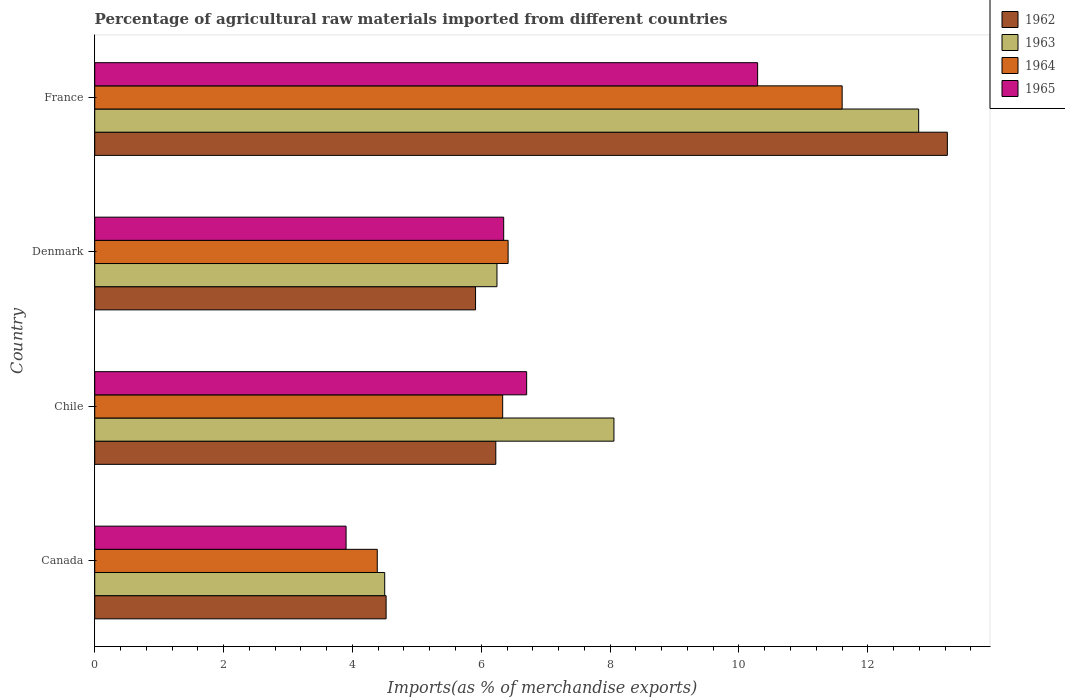How many different coloured bars are there?
Provide a succinct answer. 4. Are the number of bars per tick equal to the number of legend labels?
Give a very brief answer. Yes. Are the number of bars on each tick of the Y-axis equal?
Make the answer very short. Yes. What is the percentage of imports to different countries in 1962 in France?
Give a very brief answer. 13.24. Across all countries, what is the maximum percentage of imports to different countries in 1963?
Your answer should be very brief. 12.79. Across all countries, what is the minimum percentage of imports to different countries in 1962?
Offer a very short reply. 4.52. What is the total percentage of imports to different countries in 1964 in the graph?
Offer a very short reply. 28.74. What is the difference between the percentage of imports to different countries in 1965 in Canada and that in Chile?
Give a very brief answer. -2.8. What is the difference between the percentage of imports to different countries in 1963 in Denmark and the percentage of imports to different countries in 1964 in Canada?
Offer a very short reply. 1.86. What is the average percentage of imports to different countries in 1962 per country?
Your response must be concise. 7.47. What is the difference between the percentage of imports to different countries in 1965 and percentage of imports to different countries in 1962 in France?
Keep it short and to the point. -2.95. What is the ratio of the percentage of imports to different countries in 1962 in Canada to that in Chile?
Offer a very short reply. 0.73. Is the percentage of imports to different countries in 1963 in Canada less than that in Chile?
Offer a very short reply. Yes. Is the difference between the percentage of imports to different countries in 1965 in Chile and Denmark greater than the difference between the percentage of imports to different countries in 1962 in Chile and Denmark?
Provide a short and direct response. Yes. What is the difference between the highest and the second highest percentage of imports to different countries in 1962?
Give a very brief answer. 7.01. What is the difference between the highest and the lowest percentage of imports to different countries in 1962?
Make the answer very short. 8.71. In how many countries, is the percentage of imports to different countries in 1965 greater than the average percentage of imports to different countries in 1965 taken over all countries?
Ensure brevity in your answer.  1. What does the 1st bar from the top in Denmark represents?
Provide a short and direct response. 1965. How many bars are there?
Make the answer very short. 16. What is the difference between two consecutive major ticks on the X-axis?
Offer a very short reply. 2. Are the values on the major ticks of X-axis written in scientific E-notation?
Keep it short and to the point. No. Does the graph contain grids?
Ensure brevity in your answer.  No. How are the legend labels stacked?
Provide a succinct answer. Vertical. What is the title of the graph?
Ensure brevity in your answer.  Percentage of agricultural raw materials imported from different countries. What is the label or title of the X-axis?
Make the answer very short. Imports(as % of merchandise exports). What is the Imports(as % of merchandise exports) of 1962 in Canada?
Keep it short and to the point. 4.52. What is the Imports(as % of merchandise exports) of 1963 in Canada?
Your answer should be very brief. 4.5. What is the Imports(as % of merchandise exports) in 1964 in Canada?
Provide a short and direct response. 4.39. What is the Imports(as % of merchandise exports) in 1965 in Canada?
Keep it short and to the point. 3.9. What is the Imports(as % of merchandise exports) of 1962 in Chile?
Ensure brevity in your answer.  6.23. What is the Imports(as % of merchandise exports) of 1963 in Chile?
Ensure brevity in your answer.  8.06. What is the Imports(as % of merchandise exports) of 1964 in Chile?
Make the answer very short. 6.33. What is the Imports(as % of merchandise exports) in 1965 in Chile?
Ensure brevity in your answer.  6.7. What is the Imports(as % of merchandise exports) of 1962 in Denmark?
Offer a terse response. 5.91. What is the Imports(as % of merchandise exports) of 1963 in Denmark?
Offer a terse response. 6.24. What is the Imports(as % of merchandise exports) of 1964 in Denmark?
Provide a succinct answer. 6.42. What is the Imports(as % of merchandise exports) in 1965 in Denmark?
Offer a very short reply. 6.35. What is the Imports(as % of merchandise exports) in 1962 in France?
Ensure brevity in your answer.  13.24. What is the Imports(as % of merchandise exports) of 1963 in France?
Your response must be concise. 12.79. What is the Imports(as % of merchandise exports) in 1964 in France?
Give a very brief answer. 11.6. What is the Imports(as % of merchandise exports) in 1965 in France?
Provide a short and direct response. 10.29. Across all countries, what is the maximum Imports(as % of merchandise exports) of 1962?
Provide a succinct answer. 13.24. Across all countries, what is the maximum Imports(as % of merchandise exports) of 1963?
Your response must be concise. 12.79. Across all countries, what is the maximum Imports(as % of merchandise exports) in 1964?
Your answer should be very brief. 11.6. Across all countries, what is the maximum Imports(as % of merchandise exports) in 1965?
Keep it short and to the point. 10.29. Across all countries, what is the minimum Imports(as % of merchandise exports) in 1962?
Make the answer very short. 4.52. Across all countries, what is the minimum Imports(as % of merchandise exports) of 1963?
Make the answer very short. 4.5. Across all countries, what is the minimum Imports(as % of merchandise exports) of 1964?
Give a very brief answer. 4.39. Across all countries, what is the minimum Imports(as % of merchandise exports) in 1965?
Offer a very short reply. 3.9. What is the total Imports(as % of merchandise exports) in 1962 in the graph?
Offer a terse response. 29.9. What is the total Imports(as % of merchandise exports) in 1963 in the graph?
Offer a terse response. 31.59. What is the total Imports(as % of merchandise exports) in 1964 in the graph?
Keep it short and to the point. 28.74. What is the total Imports(as % of merchandise exports) of 1965 in the graph?
Make the answer very short. 27.24. What is the difference between the Imports(as % of merchandise exports) of 1962 in Canada and that in Chile?
Your answer should be compact. -1.7. What is the difference between the Imports(as % of merchandise exports) in 1963 in Canada and that in Chile?
Offer a very short reply. -3.56. What is the difference between the Imports(as % of merchandise exports) of 1964 in Canada and that in Chile?
Provide a succinct answer. -1.95. What is the difference between the Imports(as % of merchandise exports) in 1965 in Canada and that in Chile?
Provide a succinct answer. -2.8. What is the difference between the Imports(as % of merchandise exports) of 1962 in Canada and that in Denmark?
Provide a short and direct response. -1.39. What is the difference between the Imports(as % of merchandise exports) of 1963 in Canada and that in Denmark?
Provide a short and direct response. -1.74. What is the difference between the Imports(as % of merchandise exports) of 1964 in Canada and that in Denmark?
Provide a succinct answer. -2.03. What is the difference between the Imports(as % of merchandise exports) in 1965 in Canada and that in Denmark?
Provide a succinct answer. -2.45. What is the difference between the Imports(as % of merchandise exports) in 1962 in Canada and that in France?
Ensure brevity in your answer.  -8.71. What is the difference between the Imports(as % of merchandise exports) of 1963 in Canada and that in France?
Keep it short and to the point. -8.29. What is the difference between the Imports(as % of merchandise exports) in 1964 in Canada and that in France?
Make the answer very short. -7.22. What is the difference between the Imports(as % of merchandise exports) of 1965 in Canada and that in France?
Make the answer very short. -6.39. What is the difference between the Imports(as % of merchandise exports) of 1962 in Chile and that in Denmark?
Offer a terse response. 0.31. What is the difference between the Imports(as % of merchandise exports) of 1963 in Chile and that in Denmark?
Offer a terse response. 1.82. What is the difference between the Imports(as % of merchandise exports) in 1964 in Chile and that in Denmark?
Your answer should be compact. -0.08. What is the difference between the Imports(as % of merchandise exports) in 1965 in Chile and that in Denmark?
Provide a succinct answer. 0.36. What is the difference between the Imports(as % of merchandise exports) in 1962 in Chile and that in France?
Offer a very short reply. -7.01. What is the difference between the Imports(as % of merchandise exports) of 1963 in Chile and that in France?
Your response must be concise. -4.73. What is the difference between the Imports(as % of merchandise exports) in 1964 in Chile and that in France?
Provide a short and direct response. -5.27. What is the difference between the Imports(as % of merchandise exports) in 1965 in Chile and that in France?
Provide a succinct answer. -3.59. What is the difference between the Imports(as % of merchandise exports) in 1962 in Denmark and that in France?
Keep it short and to the point. -7.32. What is the difference between the Imports(as % of merchandise exports) of 1963 in Denmark and that in France?
Your answer should be very brief. -6.55. What is the difference between the Imports(as % of merchandise exports) of 1964 in Denmark and that in France?
Provide a succinct answer. -5.19. What is the difference between the Imports(as % of merchandise exports) of 1965 in Denmark and that in France?
Offer a very short reply. -3.94. What is the difference between the Imports(as % of merchandise exports) in 1962 in Canada and the Imports(as % of merchandise exports) in 1963 in Chile?
Your answer should be very brief. -3.54. What is the difference between the Imports(as % of merchandise exports) of 1962 in Canada and the Imports(as % of merchandise exports) of 1964 in Chile?
Your answer should be compact. -1.81. What is the difference between the Imports(as % of merchandise exports) in 1962 in Canada and the Imports(as % of merchandise exports) in 1965 in Chile?
Provide a succinct answer. -2.18. What is the difference between the Imports(as % of merchandise exports) in 1963 in Canada and the Imports(as % of merchandise exports) in 1964 in Chile?
Provide a succinct answer. -1.83. What is the difference between the Imports(as % of merchandise exports) in 1963 in Canada and the Imports(as % of merchandise exports) in 1965 in Chile?
Provide a succinct answer. -2.2. What is the difference between the Imports(as % of merchandise exports) of 1964 in Canada and the Imports(as % of merchandise exports) of 1965 in Chile?
Make the answer very short. -2.32. What is the difference between the Imports(as % of merchandise exports) of 1962 in Canada and the Imports(as % of merchandise exports) of 1963 in Denmark?
Keep it short and to the point. -1.72. What is the difference between the Imports(as % of merchandise exports) in 1962 in Canada and the Imports(as % of merchandise exports) in 1964 in Denmark?
Make the answer very short. -1.89. What is the difference between the Imports(as % of merchandise exports) in 1962 in Canada and the Imports(as % of merchandise exports) in 1965 in Denmark?
Give a very brief answer. -1.83. What is the difference between the Imports(as % of merchandise exports) in 1963 in Canada and the Imports(as % of merchandise exports) in 1964 in Denmark?
Keep it short and to the point. -1.92. What is the difference between the Imports(as % of merchandise exports) in 1963 in Canada and the Imports(as % of merchandise exports) in 1965 in Denmark?
Offer a very short reply. -1.85. What is the difference between the Imports(as % of merchandise exports) of 1964 in Canada and the Imports(as % of merchandise exports) of 1965 in Denmark?
Offer a terse response. -1.96. What is the difference between the Imports(as % of merchandise exports) of 1962 in Canada and the Imports(as % of merchandise exports) of 1963 in France?
Provide a short and direct response. -8.27. What is the difference between the Imports(as % of merchandise exports) of 1962 in Canada and the Imports(as % of merchandise exports) of 1964 in France?
Provide a succinct answer. -7.08. What is the difference between the Imports(as % of merchandise exports) in 1962 in Canada and the Imports(as % of merchandise exports) in 1965 in France?
Your answer should be very brief. -5.77. What is the difference between the Imports(as % of merchandise exports) in 1963 in Canada and the Imports(as % of merchandise exports) in 1964 in France?
Offer a very short reply. -7.1. What is the difference between the Imports(as % of merchandise exports) in 1963 in Canada and the Imports(as % of merchandise exports) in 1965 in France?
Offer a very short reply. -5.79. What is the difference between the Imports(as % of merchandise exports) in 1964 in Canada and the Imports(as % of merchandise exports) in 1965 in France?
Provide a short and direct response. -5.9. What is the difference between the Imports(as % of merchandise exports) in 1962 in Chile and the Imports(as % of merchandise exports) in 1963 in Denmark?
Make the answer very short. -0.02. What is the difference between the Imports(as % of merchandise exports) in 1962 in Chile and the Imports(as % of merchandise exports) in 1964 in Denmark?
Offer a terse response. -0.19. What is the difference between the Imports(as % of merchandise exports) in 1962 in Chile and the Imports(as % of merchandise exports) in 1965 in Denmark?
Keep it short and to the point. -0.12. What is the difference between the Imports(as % of merchandise exports) of 1963 in Chile and the Imports(as % of merchandise exports) of 1964 in Denmark?
Your answer should be compact. 1.64. What is the difference between the Imports(as % of merchandise exports) of 1963 in Chile and the Imports(as % of merchandise exports) of 1965 in Denmark?
Keep it short and to the point. 1.71. What is the difference between the Imports(as % of merchandise exports) of 1964 in Chile and the Imports(as % of merchandise exports) of 1965 in Denmark?
Keep it short and to the point. -0.02. What is the difference between the Imports(as % of merchandise exports) in 1962 in Chile and the Imports(as % of merchandise exports) in 1963 in France?
Give a very brief answer. -6.56. What is the difference between the Imports(as % of merchandise exports) in 1962 in Chile and the Imports(as % of merchandise exports) in 1964 in France?
Offer a terse response. -5.38. What is the difference between the Imports(as % of merchandise exports) of 1962 in Chile and the Imports(as % of merchandise exports) of 1965 in France?
Offer a terse response. -4.06. What is the difference between the Imports(as % of merchandise exports) of 1963 in Chile and the Imports(as % of merchandise exports) of 1964 in France?
Keep it short and to the point. -3.54. What is the difference between the Imports(as % of merchandise exports) in 1963 in Chile and the Imports(as % of merchandise exports) in 1965 in France?
Your response must be concise. -2.23. What is the difference between the Imports(as % of merchandise exports) in 1964 in Chile and the Imports(as % of merchandise exports) in 1965 in France?
Your response must be concise. -3.96. What is the difference between the Imports(as % of merchandise exports) in 1962 in Denmark and the Imports(as % of merchandise exports) in 1963 in France?
Your response must be concise. -6.88. What is the difference between the Imports(as % of merchandise exports) in 1962 in Denmark and the Imports(as % of merchandise exports) in 1964 in France?
Make the answer very short. -5.69. What is the difference between the Imports(as % of merchandise exports) of 1962 in Denmark and the Imports(as % of merchandise exports) of 1965 in France?
Ensure brevity in your answer.  -4.38. What is the difference between the Imports(as % of merchandise exports) in 1963 in Denmark and the Imports(as % of merchandise exports) in 1964 in France?
Your response must be concise. -5.36. What is the difference between the Imports(as % of merchandise exports) of 1963 in Denmark and the Imports(as % of merchandise exports) of 1965 in France?
Offer a terse response. -4.05. What is the difference between the Imports(as % of merchandise exports) in 1964 in Denmark and the Imports(as % of merchandise exports) in 1965 in France?
Provide a succinct answer. -3.87. What is the average Imports(as % of merchandise exports) in 1962 per country?
Give a very brief answer. 7.47. What is the average Imports(as % of merchandise exports) in 1963 per country?
Ensure brevity in your answer.  7.9. What is the average Imports(as % of merchandise exports) of 1964 per country?
Provide a short and direct response. 7.18. What is the average Imports(as % of merchandise exports) of 1965 per country?
Make the answer very short. 6.81. What is the difference between the Imports(as % of merchandise exports) in 1962 and Imports(as % of merchandise exports) in 1963 in Canada?
Ensure brevity in your answer.  0.02. What is the difference between the Imports(as % of merchandise exports) in 1962 and Imports(as % of merchandise exports) in 1964 in Canada?
Give a very brief answer. 0.14. What is the difference between the Imports(as % of merchandise exports) of 1962 and Imports(as % of merchandise exports) of 1965 in Canada?
Give a very brief answer. 0.62. What is the difference between the Imports(as % of merchandise exports) in 1963 and Imports(as % of merchandise exports) in 1964 in Canada?
Keep it short and to the point. 0.12. What is the difference between the Imports(as % of merchandise exports) of 1963 and Imports(as % of merchandise exports) of 1965 in Canada?
Your answer should be very brief. 0.6. What is the difference between the Imports(as % of merchandise exports) of 1964 and Imports(as % of merchandise exports) of 1965 in Canada?
Make the answer very short. 0.48. What is the difference between the Imports(as % of merchandise exports) in 1962 and Imports(as % of merchandise exports) in 1963 in Chile?
Offer a very short reply. -1.83. What is the difference between the Imports(as % of merchandise exports) in 1962 and Imports(as % of merchandise exports) in 1964 in Chile?
Offer a very short reply. -0.11. What is the difference between the Imports(as % of merchandise exports) in 1962 and Imports(as % of merchandise exports) in 1965 in Chile?
Your answer should be compact. -0.48. What is the difference between the Imports(as % of merchandise exports) of 1963 and Imports(as % of merchandise exports) of 1964 in Chile?
Ensure brevity in your answer.  1.73. What is the difference between the Imports(as % of merchandise exports) of 1963 and Imports(as % of merchandise exports) of 1965 in Chile?
Make the answer very short. 1.35. What is the difference between the Imports(as % of merchandise exports) of 1964 and Imports(as % of merchandise exports) of 1965 in Chile?
Your response must be concise. -0.37. What is the difference between the Imports(as % of merchandise exports) in 1962 and Imports(as % of merchandise exports) in 1963 in Denmark?
Ensure brevity in your answer.  -0.33. What is the difference between the Imports(as % of merchandise exports) of 1962 and Imports(as % of merchandise exports) of 1964 in Denmark?
Ensure brevity in your answer.  -0.51. What is the difference between the Imports(as % of merchandise exports) of 1962 and Imports(as % of merchandise exports) of 1965 in Denmark?
Provide a succinct answer. -0.44. What is the difference between the Imports(as % of merchandise exports) of 1963 and Imports(as % of merchandise exports) of 1964 in Denmark?
Ensure brevity in your answer.  -0.17. What is the difference between the Imports(as % of merchandise exports) in 1963 and Imports(as % of merchandise exports) in 1965 in Denmark?
Offer a very short reply. -0.1. What is the difference between the Imports(as % of merchandise exports) in 1964 and Imports(as % of merchandise exports) in 1965 in Denmark?
Your response must be concise. 0.07. What is the difference between the Imports(as % of merchandise exports) of 1962 and Imports(as % of merchandise exports) of 1963 in France?
Provide a short and direct response. 0.45. What is the difference between the Imports(as % of merchandise exports) in 1962 and Imports(as % of merchandise exports) in 1964 in France?
Provide a short and direct response. 1.63. What is the difference between the Imports(as % of merchandise exports) of 1962 and Imports(as % of merchandise exports) of 1965 in France?
Your answer should be compact. 2.95. What is the difference between the Imports(as % of merchandise exports) in 1963 and Imports(as % of merchandise exports) in 1964 in France?
Provide a succinct answer. 1.19. What is the difference between the Imports(as % of merchandise exports) in 1963 and Imports(as % of merchandise exports) in 1965 in France?
Offer a very short reply. 2.5. What is the difference between the Imports(as % of merchandise exports) in 1964 and Imports(as % of merchandise exports) in 1965 in France?
Your answer should be very brief. 1.31. What is the ratio of the Imports(as % of merchandise exports) of 1962 in Canada to that in Chile?
Ensure brevity in your answer.  0.73. What is the ratio of the Imports(as % of merchandise exports) of 1963 in Canada to that in Chile?
Provide a short and direct response. 0.56. What is the ratio of the Imports(as % of merchandise exports) in 1964 in Canada to that in Chile?
Ensure brevity in your answer.  0.69. What is the ratio of the Imports(as % of merchandise exports) of 1965 in Canada to that in Chile?
Offer a terse response. 0.58. What is the ratio of the Imports(as % of merchandise exports) in 1962 in Canada to that in Denmark?
Your answer should be compact. 0.77. What is the ratio of the Imports(as % of merchandise exports) of 1963 in Canada to that in Denmark?
Provide a short and direct response. 0.72. What is the ratio of the Imports(as % of merchandise exports) of 1964 in Canada to that in Denmark?
Keep it short and to the point. 0.68. What is the ratio of the Imports(as % of merchandise exports) of 1965 in Canada to that in Denmark?
Offer a very short reply. 0.61. What is the ratio of the Imports(as % of merchandise exports) of 1962 in Canada to that in France?
Your response must be concise. 0.34. What is the ratio of the Imports(as % of merchandise exports) of 1963 in Canada to that in France?
Ensure brevity in your answer.  0.35. What is the ratio of the Imports(as % of merchandise exports) of 1964 in Canada to that in France?
Your answer should be very brief. 0.38. What is the ratio of the Imports(as % of merchandise exports) in 1965 in Canada to that in France?
Give a very brief answer. 0.38. What is the ratio of the Imports(as % of merchandise exports) of 1962 in Chile to that in Denmark?
Your response must be concise. 1.05. What is the ratio of the Imports(as % of merchandise exports) in 1963 in Chile to that in Denmark?
Provide a succinct answer. 1.29. What is the ratio of the Imports(as % of merchandise exports) in 1965 in Chile to that in Denmark?
Provide a short and direct response. 1.06. What is the ratio of the Imports(as % of merchandise exports) in 1962 in Chile to that in France?
Your answer should be compact. 0.47. What is the ratio of the Imports(as % of merchandise exports) in 1963 in Chile to that in France?
Make the answer very short. 0.63. What is the ratio of the Imports(as % of merchandise exports) in 1964 in Chile to that in France?
Offer a very short reply. 0.55. What is the ratio of the Imports(as % of merchandise exports) in 1965 in Chile to that in France?
Provide a succinct answer. 0.65. What is the ratio of the Imports(as % of merchandise exports) of 1962 in Denmark to that in France?
Make the answer very short. 0.45. What is the ratio of the Imports(as % of merchandise exports) in 1963 in Denmark to that in France?
Give a very brief answer. 0.49. What is the ratio of the Imports(as % of merchandise exports) of 1964 in Denmark to that in France?
Keep it short and to the point. 0.55. What is the ratio of the Imports(as % of merchandise exports) in 1965 in Denmark to that in France?
Make the answer very short. 0.62. What is the difference between the highest and the second highest Imports(as % of merchandise exports) of 1962?
Provide a short and direct response. 7.01. What is the difference between the highest and the second highest Imports(as % of merchandise exports) of 1963?
Provide a short and direct response. 4.73. What is the difference between the highest and the second highest Imports(as % of merchandise exports) in 1964?
Your response must be concise. 5.19. What is the difference between the highest and the second highest Imports(as % of merchandise exports) in 1965?
Make the answer very short. 3.59. What is the difference between the highest and the lowest Imports(as % of merchandise exports) in 1962?
Make the answer very short. 8.71. What is the difference between the highest and the lowest Imports(as % of merchandise exports) of 1963?
Keep it short and to the point. 8.29. What is the difference between the highest and the lowest Imports(as % of merchandise exports) of 1964?
Offer a terse response. 7.22. What is the difference between the highest and the lowest Imports(as % of merchandise exports) of 1965?
Your answer should be very brief. 6.39. 